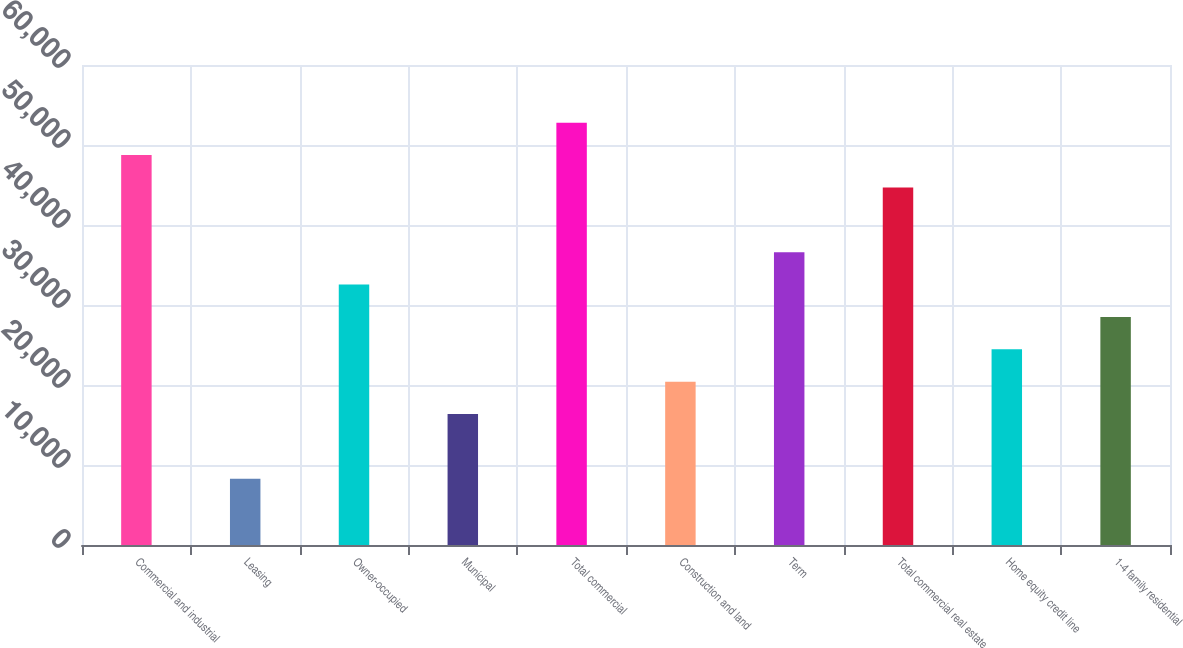Convert chart. <chart><loc_0><loc_0><loc_500><loc_500><bar_chart><fcel>Commercial and industrial<fcel>Leasing<fcel>Owner-occupied<fcel>Municipal<fcel>Total commercial<fcel>Construction and land<fcel>Term<fcel>Total commercial real estate<fcel>Home equity credit line<fcel>1-4 family residential<nl><fcel>48742.6<fcel>8279.6<fcel>32557.4<fcel>16372.2<fcel>52788.9<fcel>20418.5<fcel>36603.7<fcel>44696.3<fcel>24464.8<fcel>28511.1<nl></chart> 